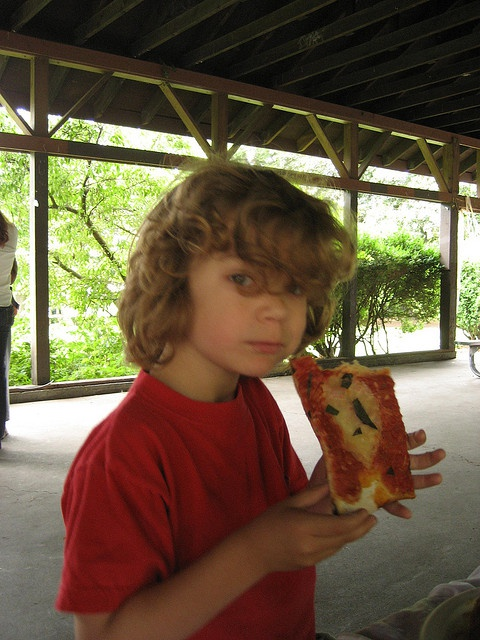Describe the objects in this image and their specific colors. I can see people in black, maroon, and brown tones, pizza in black, maroon, and olive tones, people in black, gray, and darkgray tones, and bench in black, white, darkgray, and gray tones in this image. 